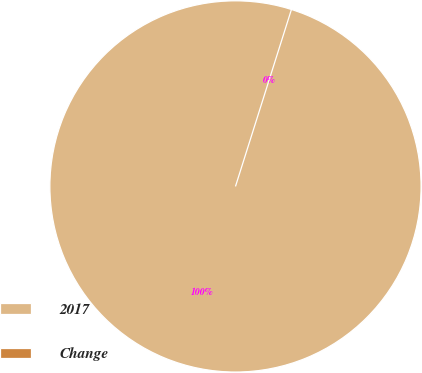Convert chart to OTSL. <chart><loc_0><loc_0><loc_500><loc_500><pie_chart><fcel>2017<fcel>Change<nl><fcel>100.0%<fcel>0.0%<nl></chart> 